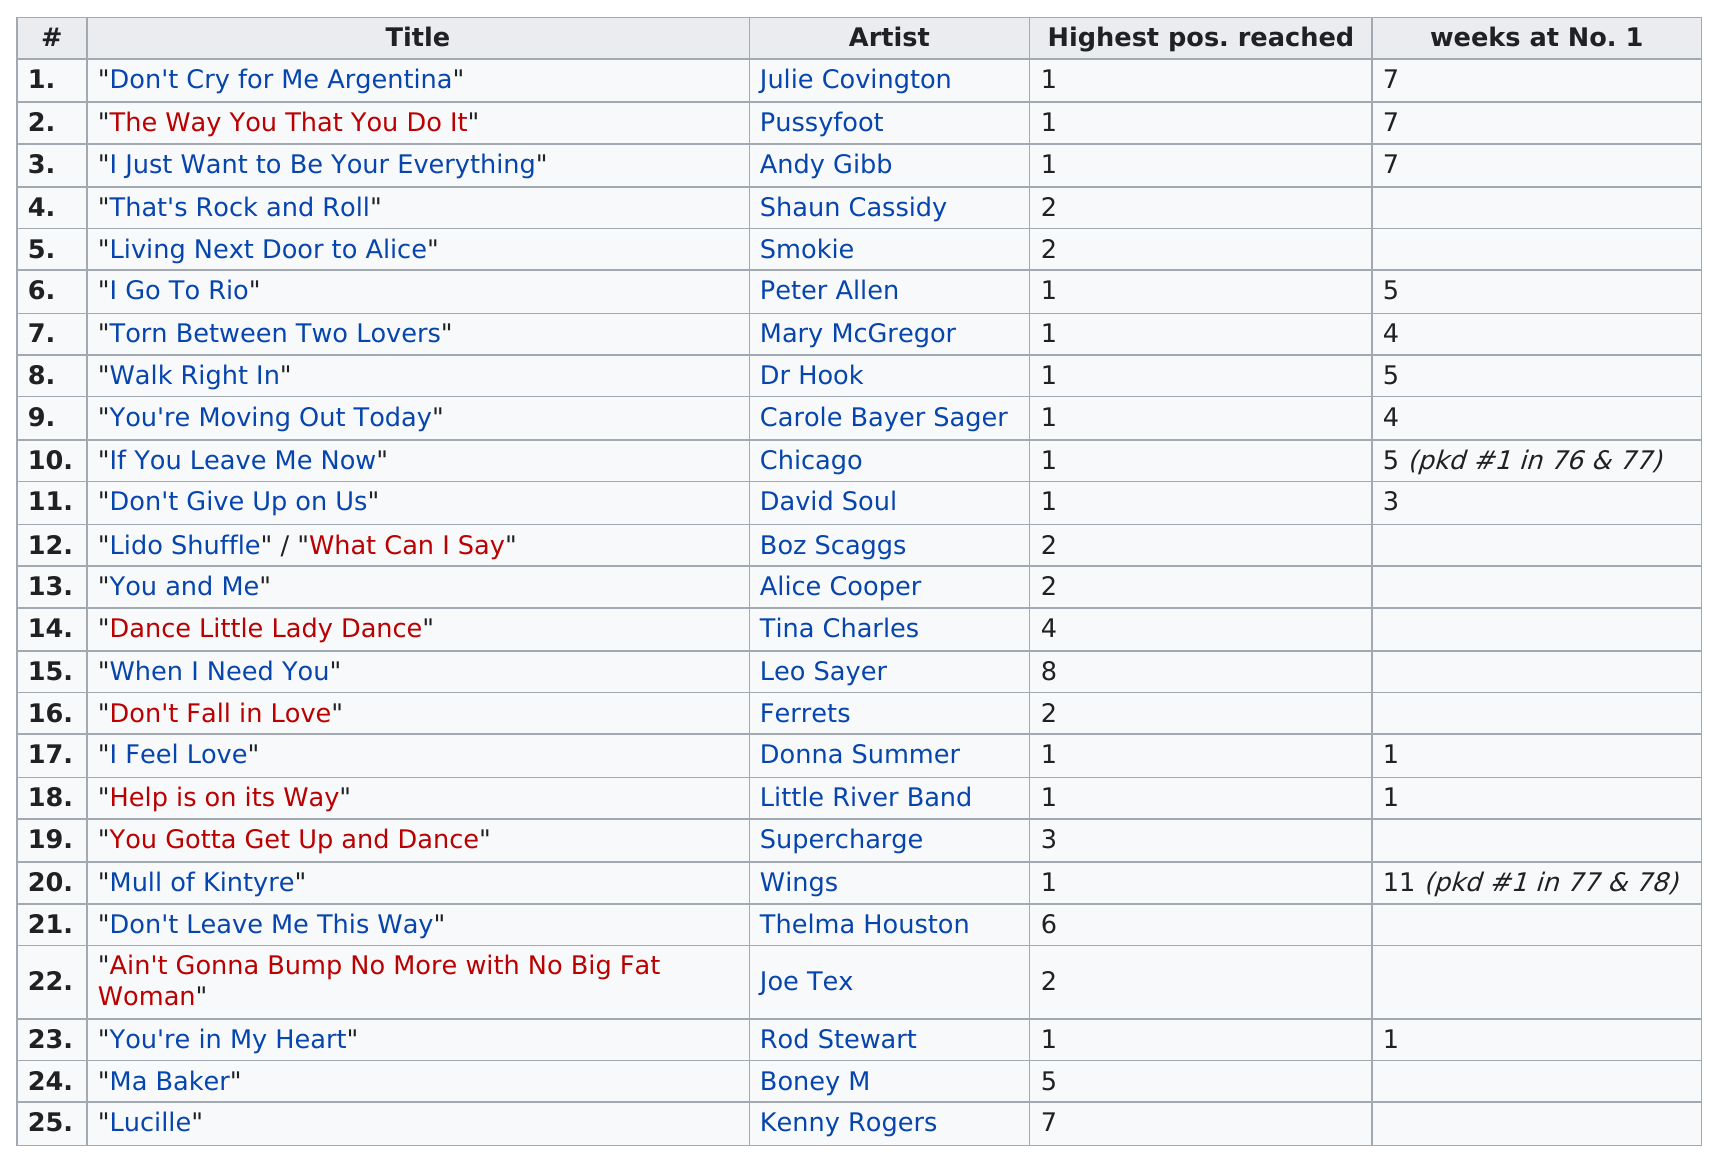List a handful of essential elements in this visual. There were three singles that reached number one on the charts for only one week. Julie Covington's "Don't Cry for Me Argentina" spent a total of 7 weeks at the top of Australia's singles chart. Julie Covington's single 'Don't Cry for Me Argentina' was at number 1 on the charts for 7 weeks in 1977. You're Moving Out Today" stayed at number one for the longest amount of time, as opposed to "I Feel Love. I claim that for a total of 5 consecutive weeks, the song "Walk Right In" by Dr. Hook held the top position on the charts. 